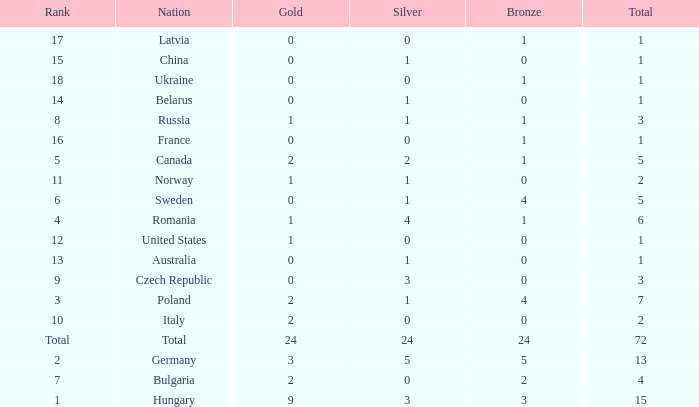How many golds have 3 as the rank, with a total greater than 7? 0.0. 